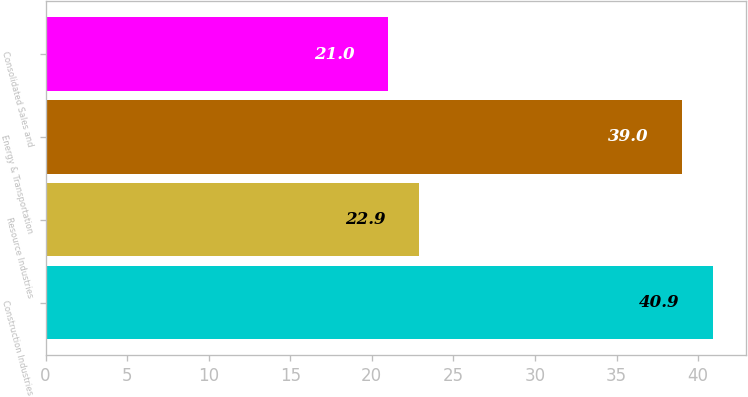<chart> <loc_0><loc_0><loc_500><loc_500><bar_chart><fcel>Construction Industries<fcel>Resource Industries<fcel>Energy & Transportation<fcel>Consolidated Sales and<nl><fcel>40.9<fcel>22.9<fcel>39<fcel>21<nl></chart> 